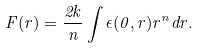Convert formula to latex. <formula><loc_0><loc_0><loc_500><loc_500>F ( r ) = \frac { 2 k } { n } \int \epsilon ( 0 , r ) r ^ { n } d r .</formula> 